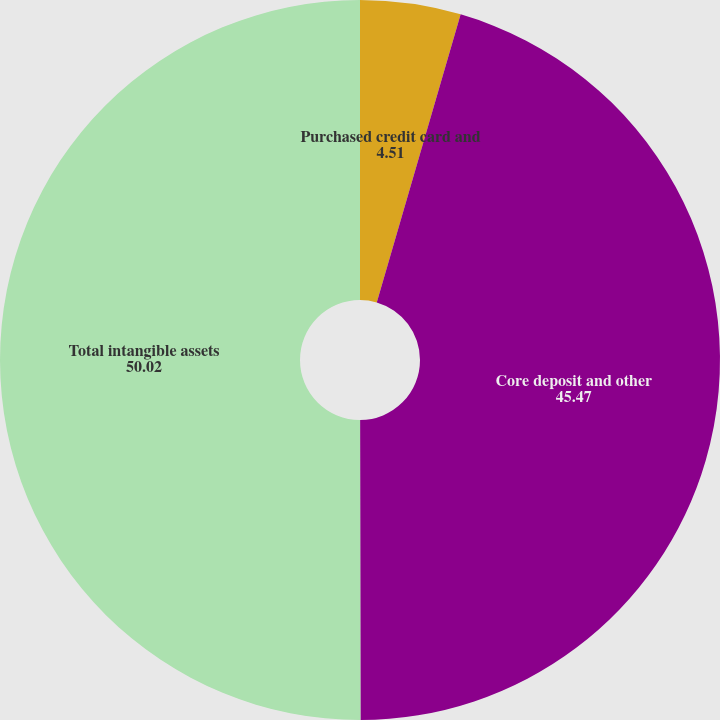<chart> <loc_0><loc_0><loc_500><loc_500><pie_chart><fcel>Purchased credit card and<fcel>Core deposit and other<fcel>Total intangible assets<nl><fcel>4.51%<fcel>45.47%<fcel>50.02%<nl></chart> 